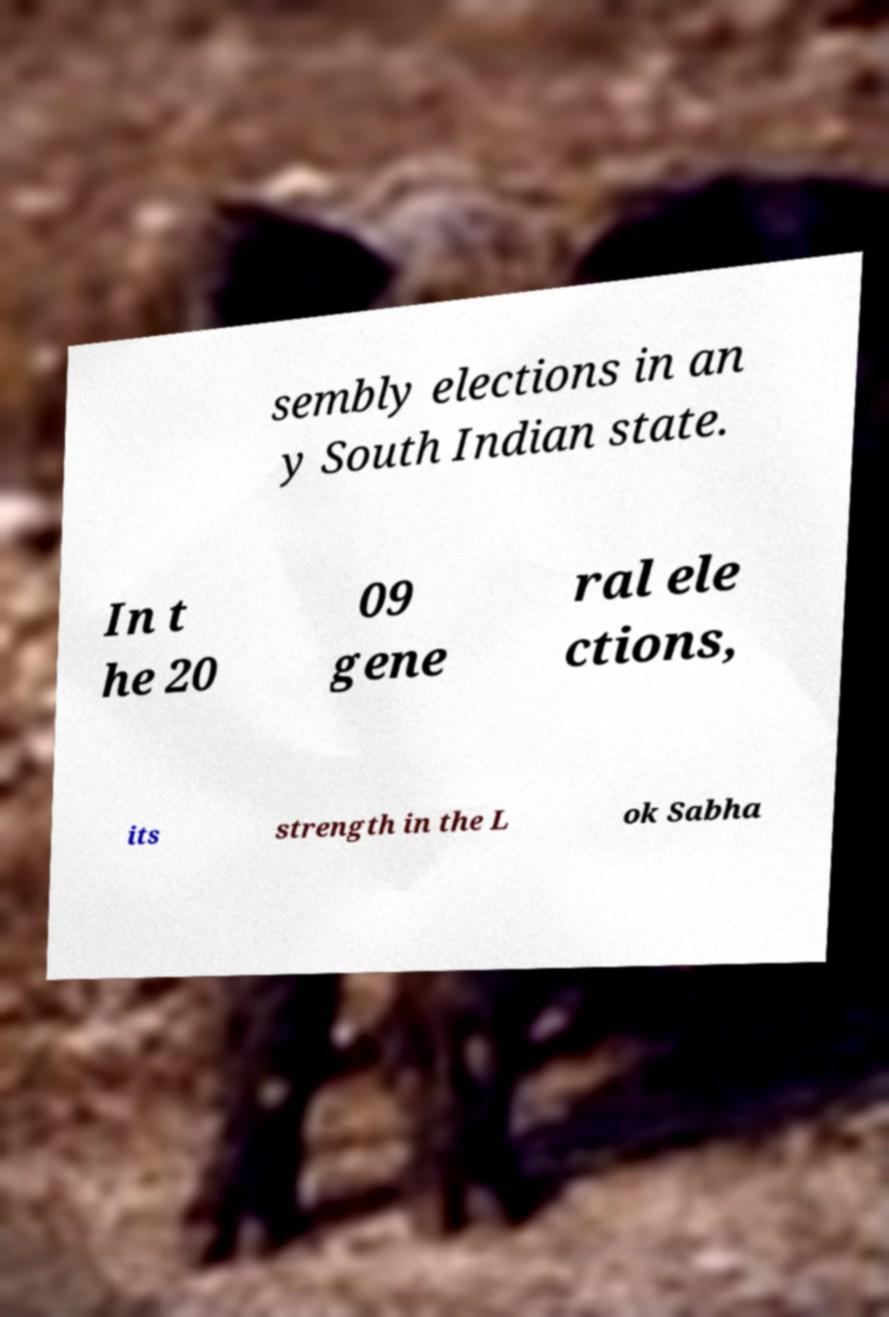Can you accurately transcribe the text from the provided image for me? sembly elections in an y South Indian state. In t he 20 09 gene ral ele ctions, its strength in the L ok Sabha 